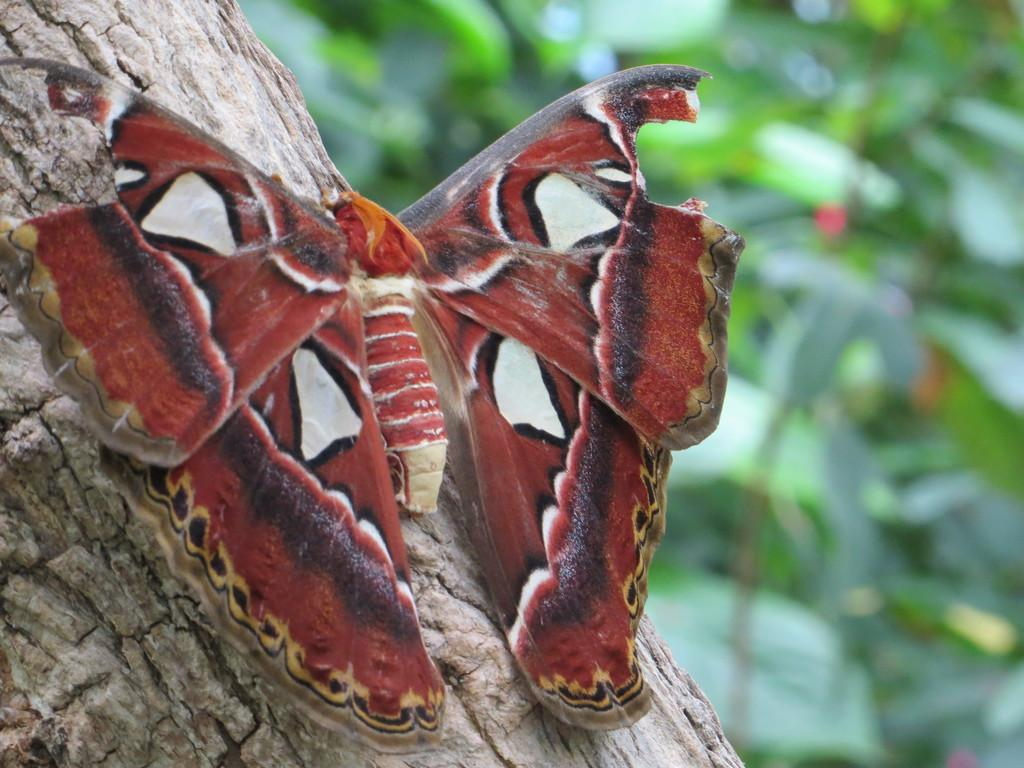What is the main subject of the image? There is a butterfly on a tree in the image. How would you describe the background of the image? The background of the image is blurred. What type of environment can be seen in the background? There is greenery visible in the background of the image. What is the answer to the riddle written on the tree in the image? There is no riddle written on the tree in the image. Who is the owner of the butterfly in the image? Butterflies are wild creatures and do not have owners. 